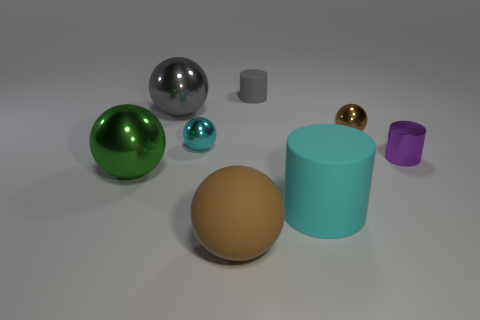Subtract all big cylinders. How many cylinders are left? 2 Subtract 3 cylinders. How many cylinders are left? 0 Add 2 cyan metallic spheres. How many objects exist? 10 Subtract all cyan cylinders. How many cylinders are left? 2 Subtract all tiny things. Subtract all green metallic objects. How many objects are left? 3 Add 5 green shiny things. How many green shiny things are left? 6 Add 8 large cyan balls. How many large cyan balls exist? 8 Subtract 0 brown cubes. How many objects are left? 8 Subtract all cylinders. How many objects are left? 5 Subtract all gray balls. Subtract all blue cubes. How many balls are left? 4 